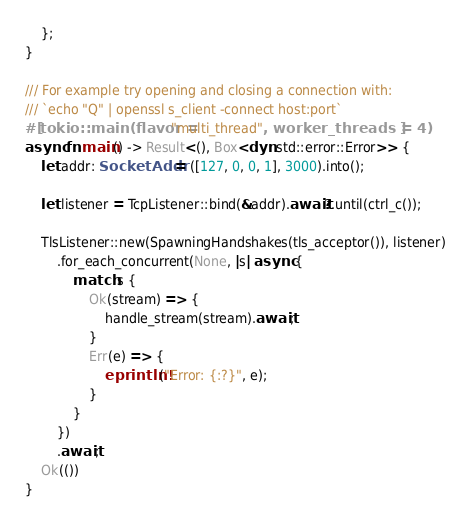<code> <loc_0><loc_0><loc_500><loc_500><_Rust_>    };
}

/// For example try opening and closing a connection with:
/// `echo "Q" | openssl s_client -connect host:port`
#[tokio::main(flavor = "multi_thread", worker_threads = 4)]
async fn main() -> Result<(), Box<dyn std::error::Error>> {
    let addr: SocketAddr = ([127, 0, 0, 1], 3000).into();

    let listener = TcpListener::bind(&addr).await?.until(ctrl_c());

    TlsListener::new(SpawningHandshakes(tls_acceptor()), listener)
        .for_each_concurrent(None, |s| async {
            match s {
                Ok(stream) => {
                    handle_stream(stream).await;
                }
                Err(e) => {
                    eprintln!("Error: {:?}", e);
                }
            }
        })
        .await;
    Ok(())
}
</code> 